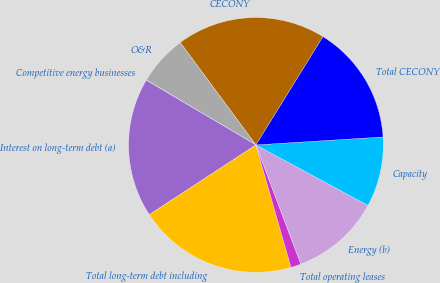Convert chart to OTSL. <chart><loc_0><loc_0><loc_500><loc_500><pie_chart><fcel>CECONY<fcel>O&R<fcel>Competitive energy businesses<fcel>Interest on long-term debt (a)<fcel>Total long-term debt including<fcel>Total operating leases<fcel>Energy (b)<fcel>Capacity<fcel>Total CECONY<nl><fcel>18.96%<fcel>6.35%<fcel>0.04%<fcel>17.7%<fcel>20.22%<fcel>1.3%<fcel>11.39%<fcel>8.87%<fcel>15.18%<nl></chart> 